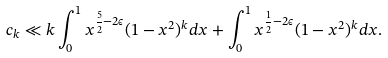<formula> <loc_0><loc_0><loc_500><loc_500>c _ { k } \ll k \int _ { 0 } ^ { 1 } x ^ { \frac { 5 } { 2 } - 2 \epsilon } ( 1 - x ^ { 2 } ) ^ { k } d x + \int _ { 0 } ^ { 1 } x ^ { \frac { 1 } { 2 } - 2 \epsilon } ( 1 - x ^ { 2 } ) ^ { k } d x .</formula> 